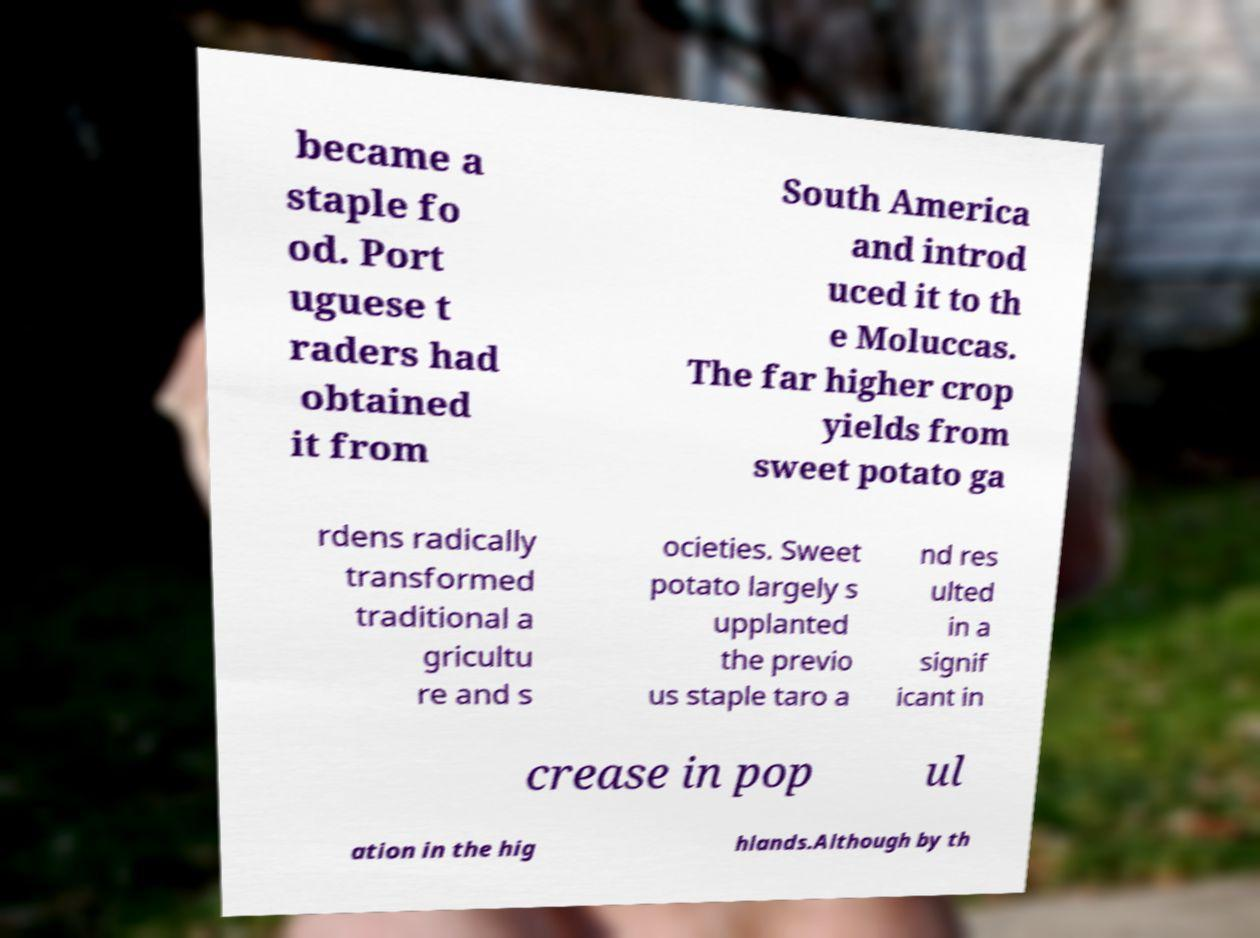Could you assist in decoding the text presented in this image and type it out clearly? became a staple fo od. Port uguese t raders had obtained it from South America and introd uced it to th e Moluccas. The far higher crop yields from sweet potato ga rdens radically transformed traditional a gricultu re and s ocieties. Sweet potato largely s upplanted the previo us staple taro a nd res ulted in a signif icant in crease in pop ul ation in the hig hlands.Although by th 